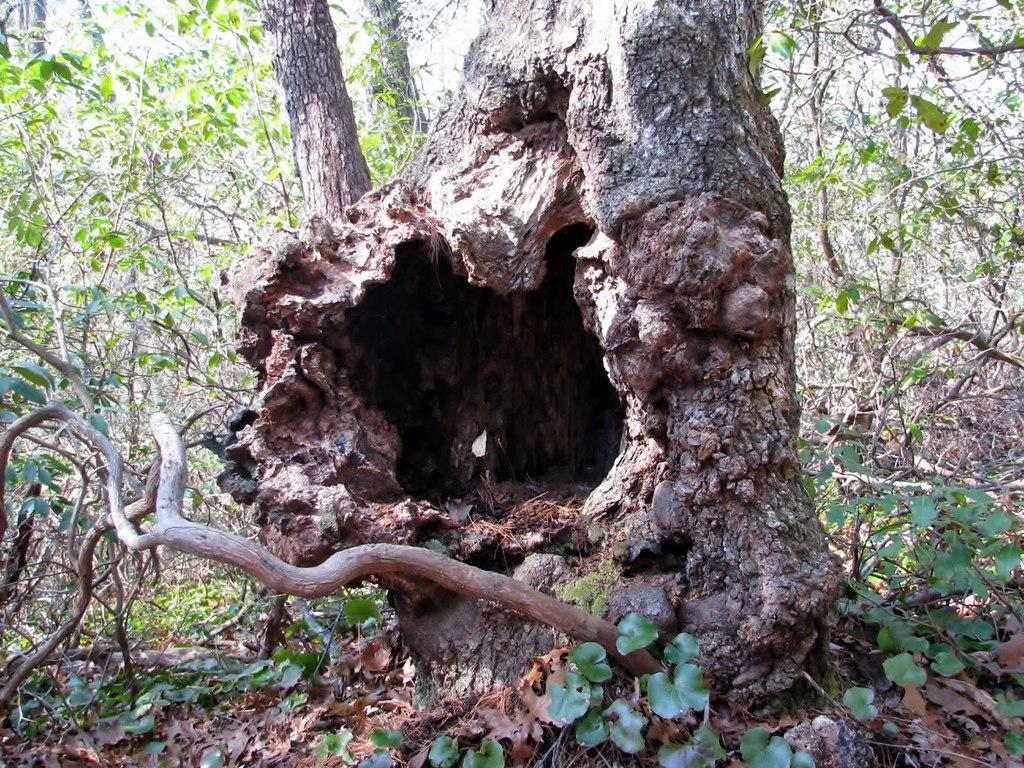What type of plant structures can be seen in the image? There are tree trunks, green leaves, and branches in the image. the image. What is the color of the leaves in the image? The leaves in the image are green. Can you describe a specific feature of the branches in the image? The image features a hole on a branch. What type of discussion is taking place near the tree trunks in the image? There is no discussion taking place in the image; it only features tree trunks, green leaves, branches, and a hole on a branch. Can you see a basin filled with water near the tree trunks in the image? There is no basin filled with water present in the image. 